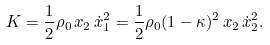<formula> <loc_0><loc_0><loc_500><loc_500>K = \frac { 1 } { 2 } \rho _ { 0 } \, x _ { 2 } \, \dot { x } _ { 1 } ^ { 2 } = \frac { 1 } { 2 } \rho _ { 0 } ( 1 - \kappa ) ^ { 2 } \, x _ { 2 } \, \dot { x } _ { 2 } ^ { 2 } .</formula> 